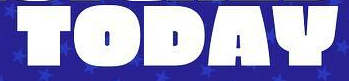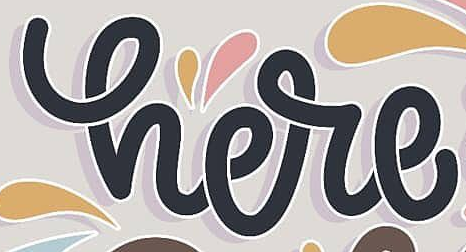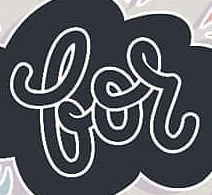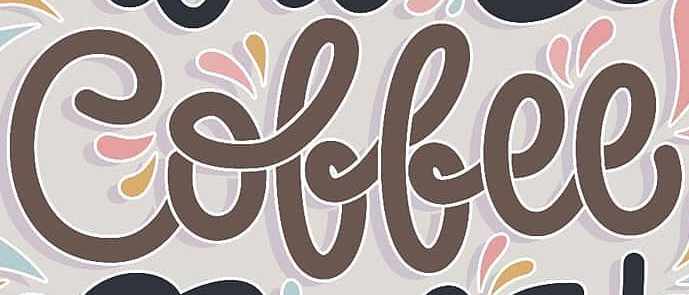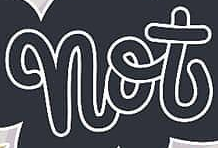Read the text content from these images in order, separated by a semicolon. TODAY; here; for; Coffee; not 